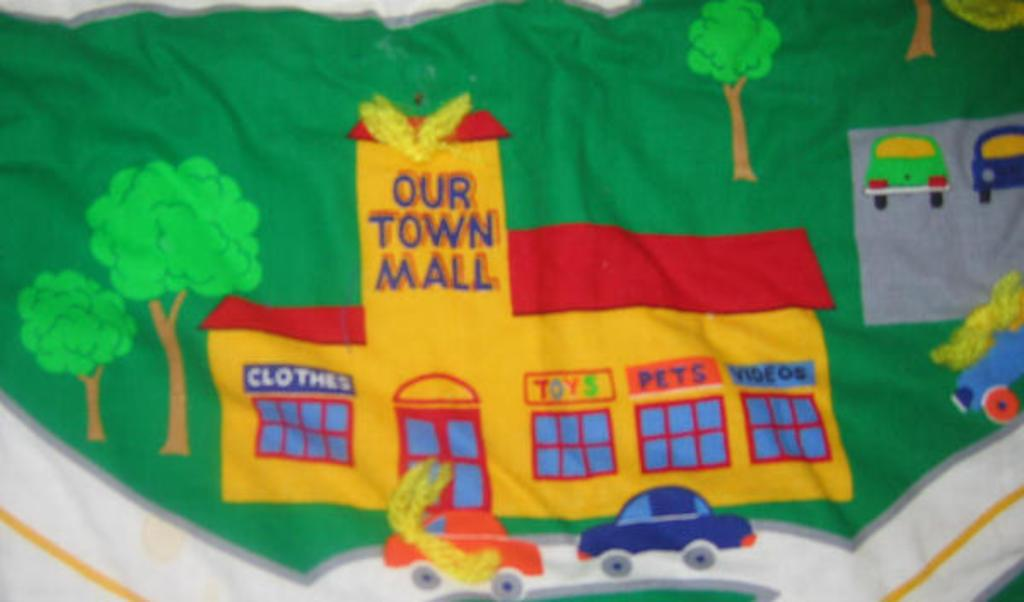What is the main feature of the image? There is a banner in the image. What types of images are present on the banner? The banner contains pictures of a building, cars, trees, and grass. Can you describe the content of the banner in more detail? The banner features pictures of a building, cars, trees, and grass, which suggests it might be related to an urban or natural environment. What type of coat is the person wearing in the image? There is no person present in the image, only a banner with pictures of a building, cars, trees, and grass. 